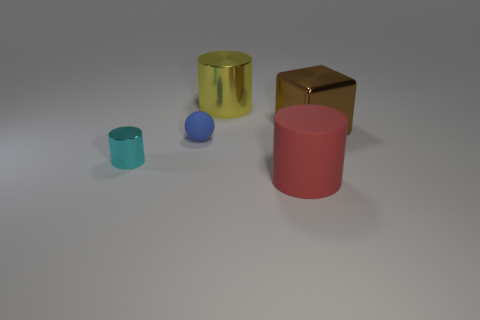Is the number of yellow metallic cylinders that are in front of the big red rubber cylinder the same as the number of large brown rubber blocks?
Offer a terse response. Yes. What material is the large object that is left of the cylinder in front of the cylinder to the left of the small matte sphere?
Your response must be concise. Metal. What number of objects are tiny cyan metallic cylinders in front of the yellow cylinder or large red metallic cylinders?
Give a very brief answer. 1. What number of objects are small cylinders or things that are behind the brown shiny cube?
Your answer should be very brief. 2. What number of red objects are in front of the big cylinder in front of the big cylinder that is behind the sphere?
Your response must be concise. 0. What material is the cyan cylinder that is the same size as the matte ball?
Your response must be concise. Metal. Are there any brown metal things that have the same size as the blue thing?
Provide a short and direct response. No. The cube is what color?
Provide a succinct answer. Brown. The large cylinder that is in front of the large cylinder left of the big red cylinder is what color?
Your response must be concise. Red. What is the shape of the big object that is on the right side of the matte object in front of the small thing that is right of the small cyan metal object?
Your answer should be very brief. Cube. 